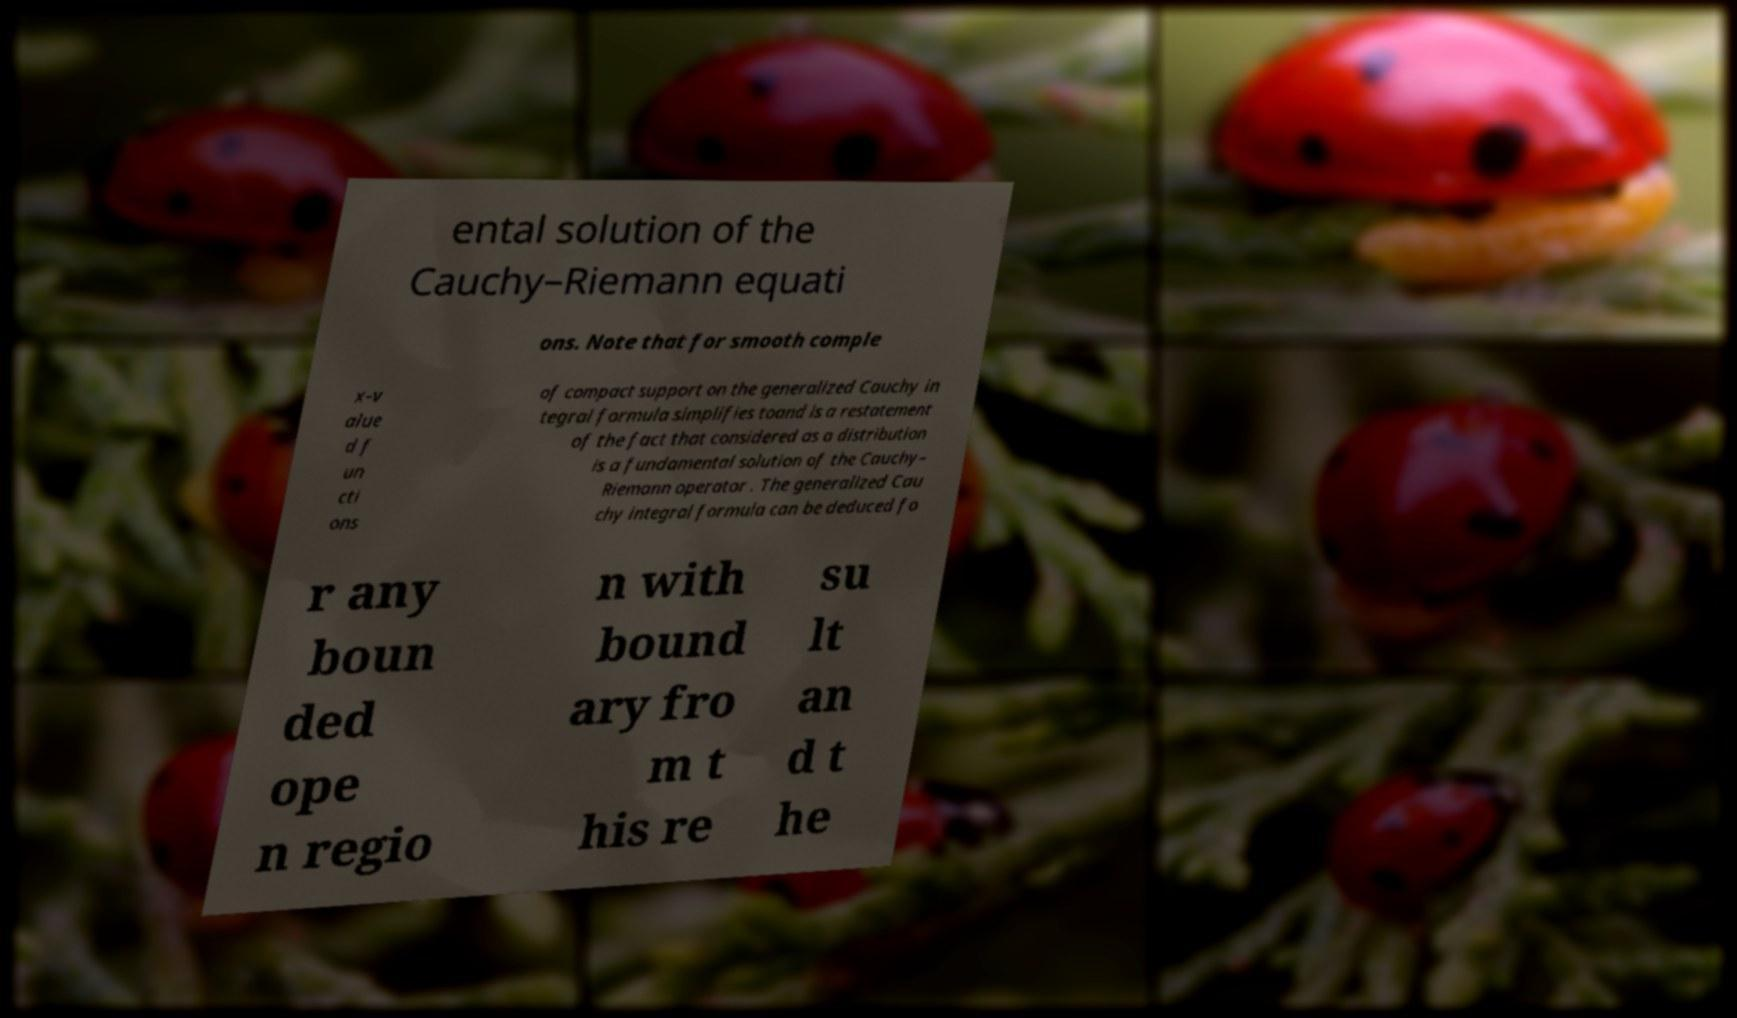Please read and relay the text visible in this image. What does it say? ental solution of the Cauchy–Riemann equati ons. Note that for smooth comple x-v alue d f un cti ons of compact support on the generalized Cauchy in tegral formula simplifies toand is a restatement of the fact that considered as a distribution is a fundamental solution of the Cauchy– Riemann operator . The generalized Cau chy integral formula can be deduced fo r any boun ded ope n regio n with bound ary fro m t his re su lt an d t he 